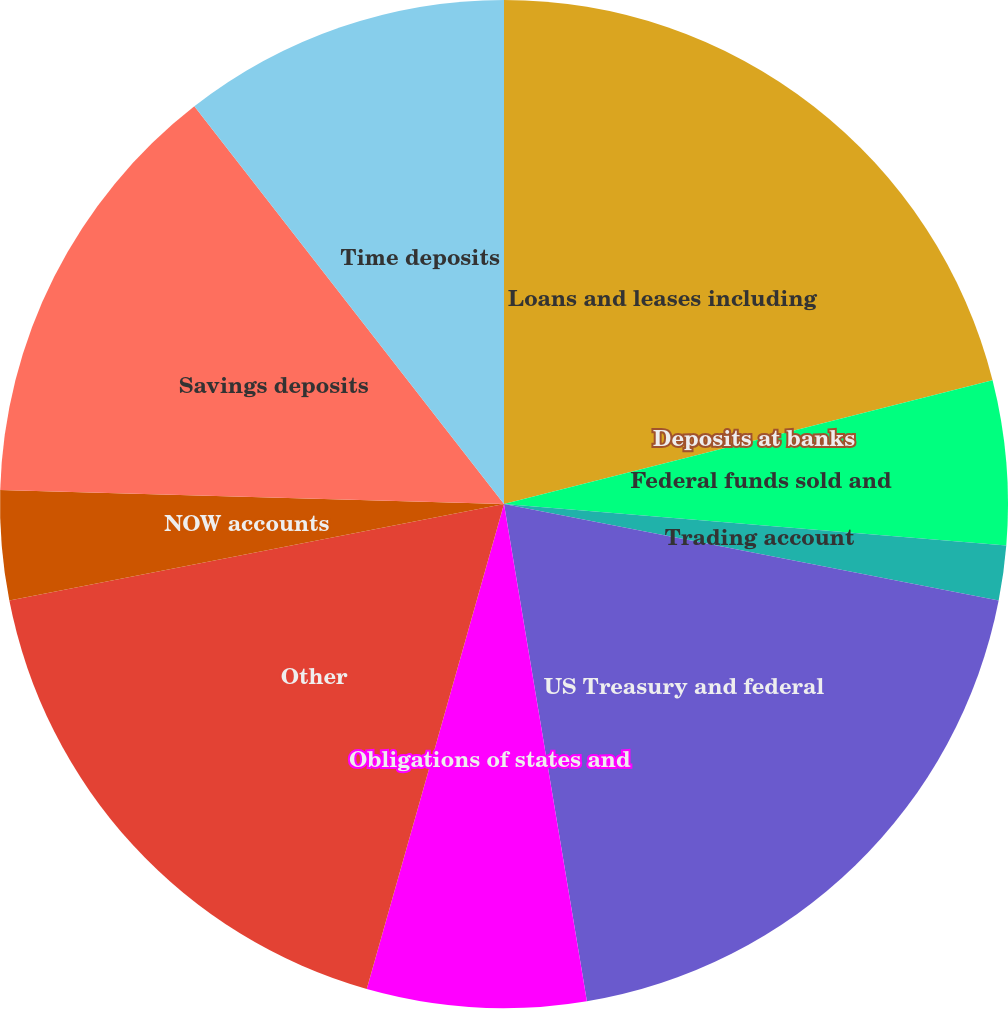<chart> <loc_0><loc_0><loc_500><loc_500><pie_chart><fcel>Loans and leases including<fcel>Deposits at banks<fcel>Federal funds sold and<fcel>Trading account<fcel>US Treasury and federal<fcel>Obligations of states and<fcel>Other<fcel>NOW accounts<fcel>Savings deposits<fcel>Time deposits<nl><fcel>21.05%<fcel>0.0%<fcel>5.26%<fcel>1.76%<fcel>19.3%<fcel>7.02%<fcel>17.54%<fcel>3.51%<fcel>14.03%<fcel>10.53%<nl></chart> 